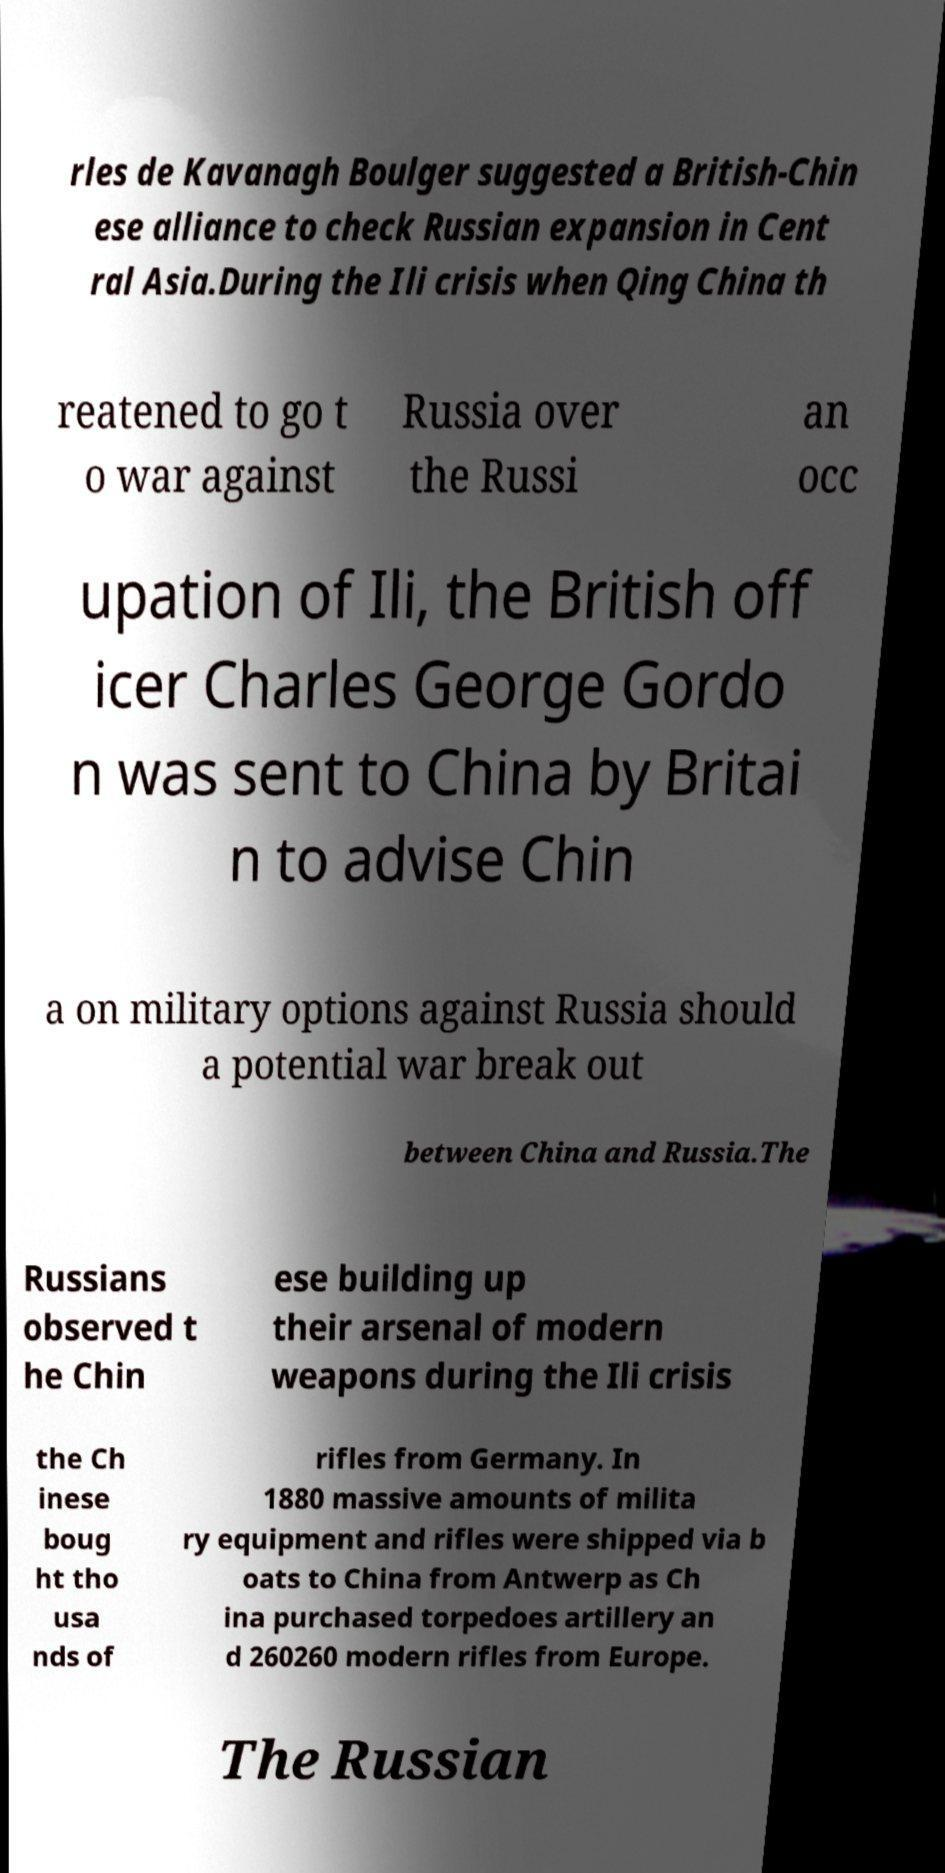Can you read and provide the text displayed in the image?This photo seems to have some interesting text. Can you extract and type it out for me? rles de Kavanagh Boulger suggested a British-Chin ese alliance to check Russian expansion in Cent ral Asia.During the Ili crisis when Qing China th reatened to go t o war against Russia over the Russi an occ upation of Ili, the British off icer Charles George Gordo n was sent to China by Britai n to advise Chin a on military options against Russia should a potential war break out between China and Russia.The Russians observed t he Chin ese building up their arsenal of modern weapons during the Ili crisis the Ch inese boug ht tho usa nds of rifles from Germany. In 1880 massive amounts of milita ry equipment and rifles were shipped via b oats to China from Antwerp as Ch ina purchased torpedoes artillery an d 260260 modern rifles from Europe. The Russian 